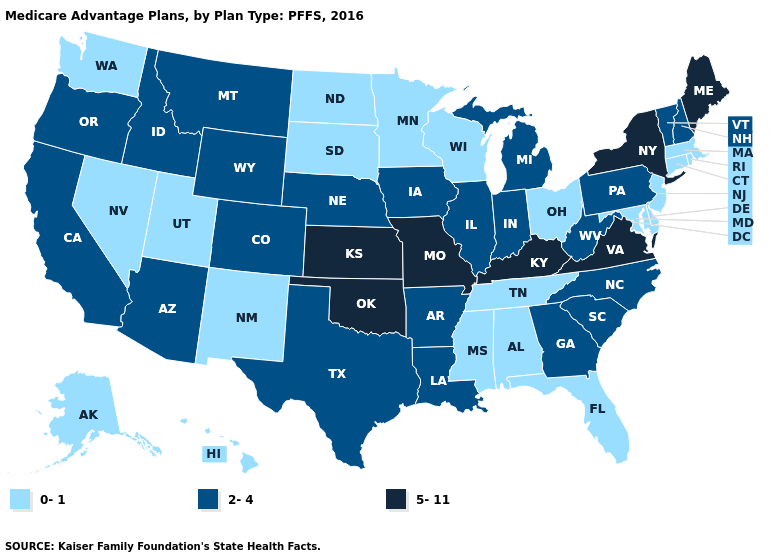What is the lowest value in states that border Montana?
Write a very short answer. 0-1. What is the value of New York?
Concise answer only. 5-11. Does the first symbol in the legend represent the smallest category?
Short answer required. Yes. Which states have the lowest value in the South?
Quick response, please. Alabama, Delaware, Florida, Maryland, Mississippi, Tennessee. Name the states that have a value in the range 5-11?
Keep it brief. Kansas, Kentucky, Maine, Missouri, New York, Oklahoma, Virginia. What is the value of Minnesota?
Short answer required. 0-1. Which states have the lowest value in the USA?
Answer briefly. Alaska, Alabama, Connecticut, Delaware, Florida, Hawaii, Massachusetts, Maryland, Minnesota, Mississippi, North Dakota, New Jersey, New Mexico, Nevada, Ohio, Rhode Island, South Dakota, Tennessee, Utah, Washington, Wisconsin. Name the states that have a value in the range 2-4?
Answer briefly. Arkansas, Arizona, California, Colorado, Georgia, Iowa, Idaho, Illinois, Indiana, Louisiana, Michigan, Montana, North Carolina, Nebraska, New Hampshire, Oregon, Pennsylvania, South Carolina, Texas, Vermont, West Virginia, Wyoming. Does Indiana have the lowest value in the USA?
Be succinct. No. Does Wisconsin have the same value as New York?
Be succinct. No. Name the states that have a value in the range 0-1?
Short answer required. Alaska, Alabama, Connecticut, Delaware, Florida, Hawaii, Massachusetts, Maryland, Minnesota, Mississippi, North Dakota, New Jersey, New Mexico, Nevada, Ohio, Rhode Island, South Dakota, Tennessee, Utah, Washington, Wisconsin. Among the states that border North Dakota , which have the highest value?
Keep it brief. Montana. What is the highest value in the South ?
Quick response, please. 5-11. What is the value of New Hampshire?
Concise answer only. 2-4. Which states have the highest value in the USA?
Keep it brief. Kansas, Kentucky, Maine, Missouri, New York, Oklahoma, Virginia. 